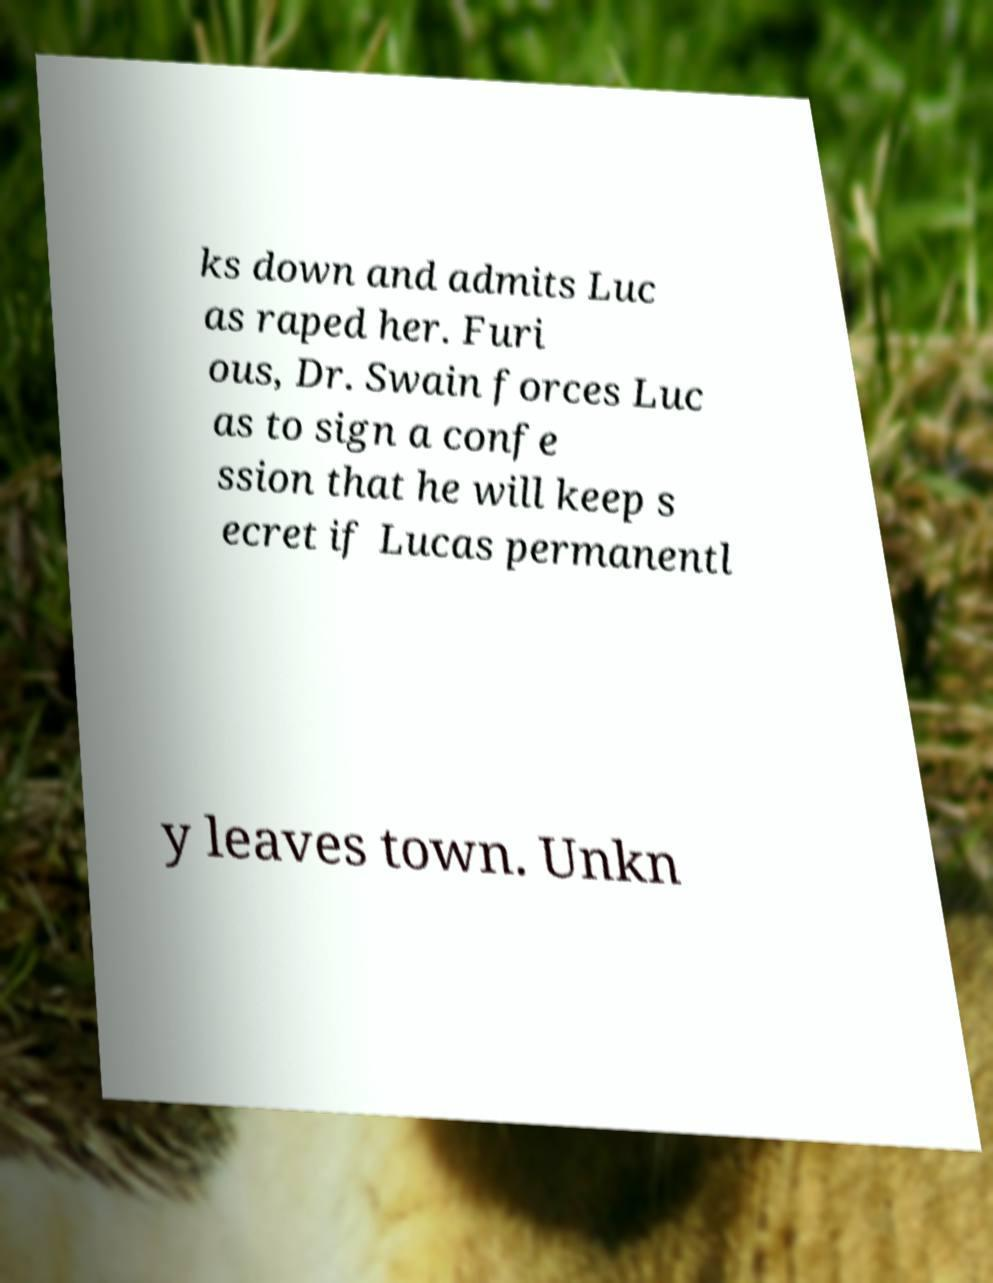Please read and relay the text visible in this image. What does it say? ks down and admits Luc as raped her. Furi ous, Dr. Swain forces Luc as to sign a confe ssion that he will keep s ecret if Lucas permanentl y leaves town. Unkn 